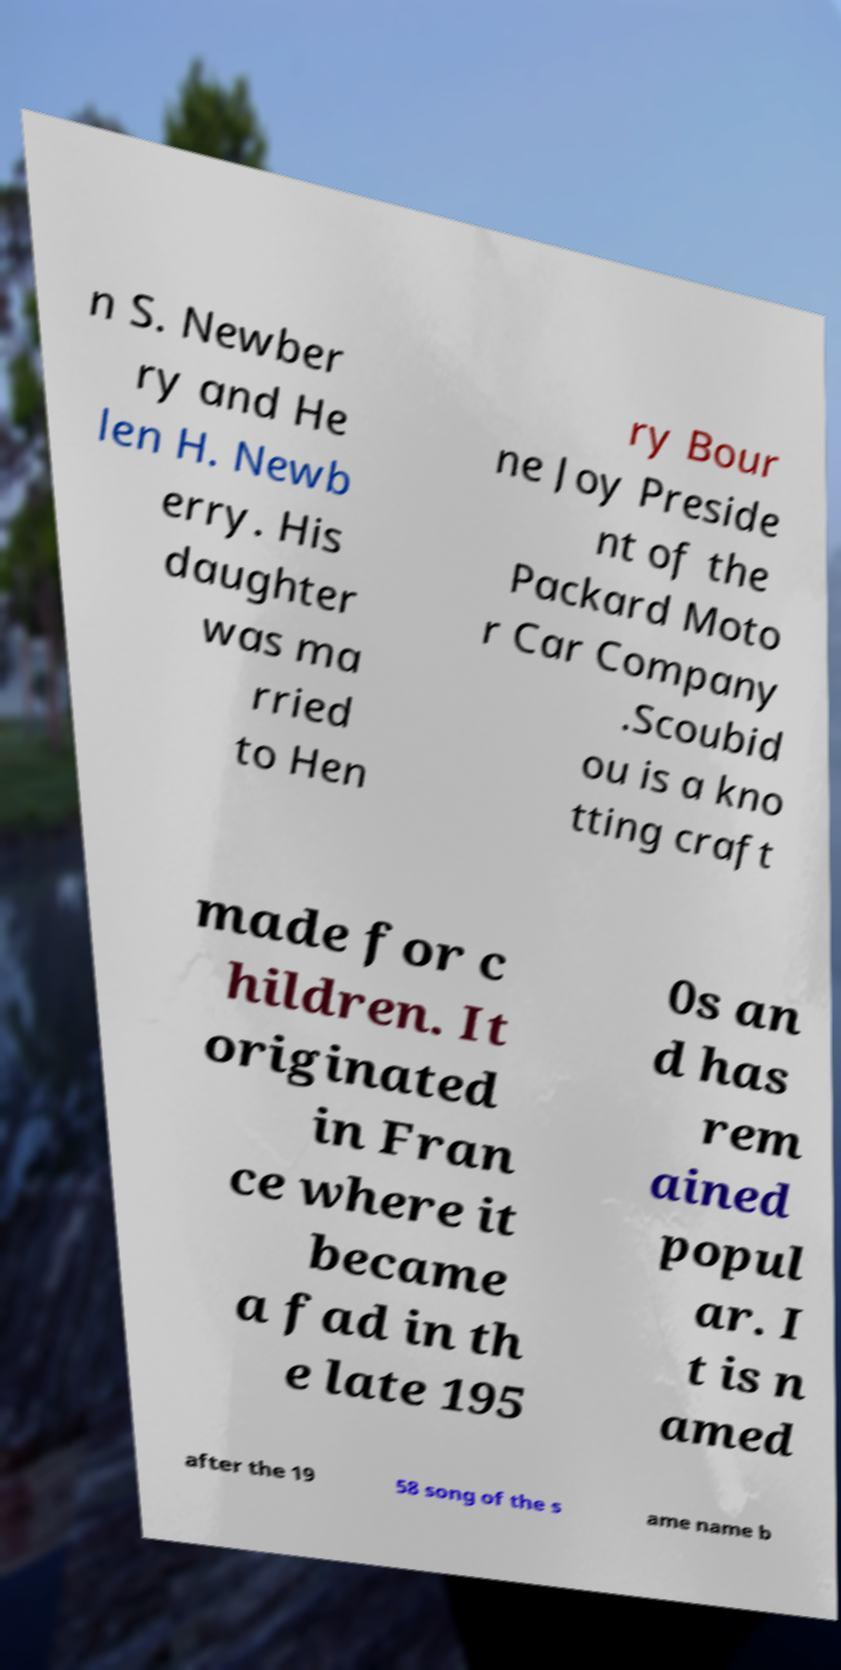I need the written content from this picture converted into text. Can you do that? n S. Newber ry and He len H. Newb erry. His daughter was ma rried to Hen ry Bour ne Joy Preside nt of the Packard Moto r Car Company .Scoubid ou is a kno tting craft made for c hildren. It originated in Fran ce where it became a fad in th e late 195 0s an d has rem ained popul ar. I t is n amed after the 19 58 song of the s ame name b 